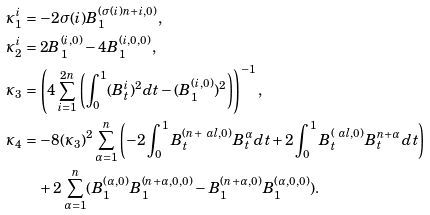Convert formula to latex. <formula><loc_0><loc_0><loc_500><loc_500>\kappa ^ { i } _ { 1 } & = - 2 \sigma ( i ) B ^ { ( \sigma ( i ) n + i , 0 ) } _ { 1 } , \\ \kappa ^ { i } _ { 2 } & = 2 B ^ { ( i , 0 ) } _ { 1 } - 4 B ^ { ( i , 0 , 0 ) } _ { 1 } , \\ \kappa _ { 3 } & = \left ( 4 \sum _ { i = 1 } ^ { 2 n } \left ( \int _ { 0 } ^ { 1 } ( B ^ { i } _ { t } ) ^ { 2 } d t - ( B ^ { ( i , 0 ) } _ { 1 } ) ^ { 2 } \right ) \right ) ^ { - 1 } , \\ \kappa _ { 4 } & = - 8 ( \kappa _ { 3 } ) ^ { 2 } \sum _ { \alpha = 1 } ^ { n } \left ( - 2 \int _ { 0 } ^ { 1 } B ^ { ( n + \ a l , 0 ) } _ { t } B ^ { \alpha } _ { t } d t + 2 \int _ { 0 } ^ { 1 } B ^ { ( \ a l , 0 ) } _ { t } B ^ { n + \alpha } _ { t } d t \right ) \\ & \quad + 2 \sum _ { \alpha = 1 } ^ { n } ( B ^ { ( \alpha , 0 ) } _ { 1 } B ^ { ( n + \alpha , 0 , 0 ) } _ { 1 } - B ^ { ( n + \alpha , 0 ) } _ { 1 } B ^ { ( \alpha , 0 , 0 ) } _ { 1 } ) .</formula> 